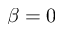Convert formula to latex. <formula><loc_0><loc_0><loc_500><loc_500>\beta = 0</formula> 